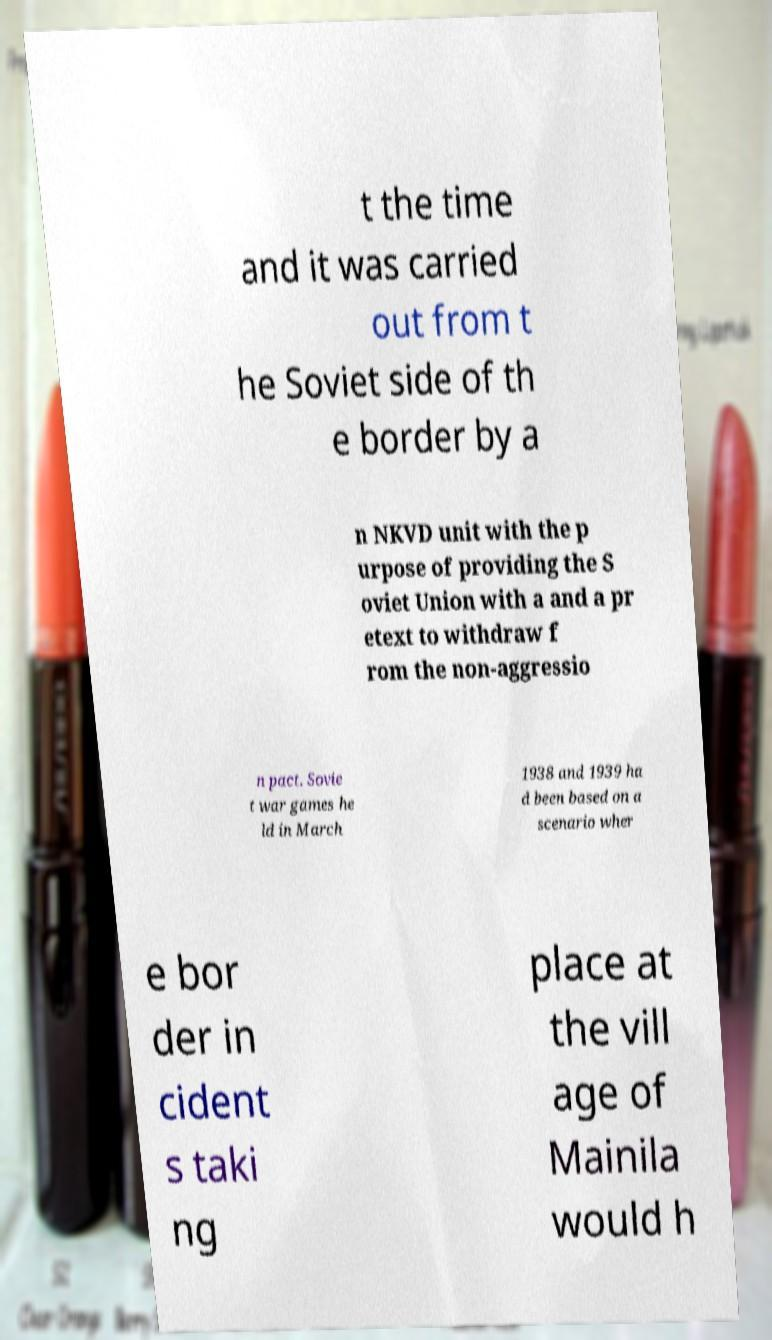Can you accurately transcribe the text from the provided image for me? t the time and it was carried out from t he Soviet side of th e border by a n NKVD unit with the p urpose of providing the S oviet Union with a and a pr etext to withdraw f rom the non-aggressio n pact. Sovie t war games he ld in March 1938 and 1939 ha d been based on a scenario wher e bor der in cident s taki ng place at the vill age of Mainila would h 